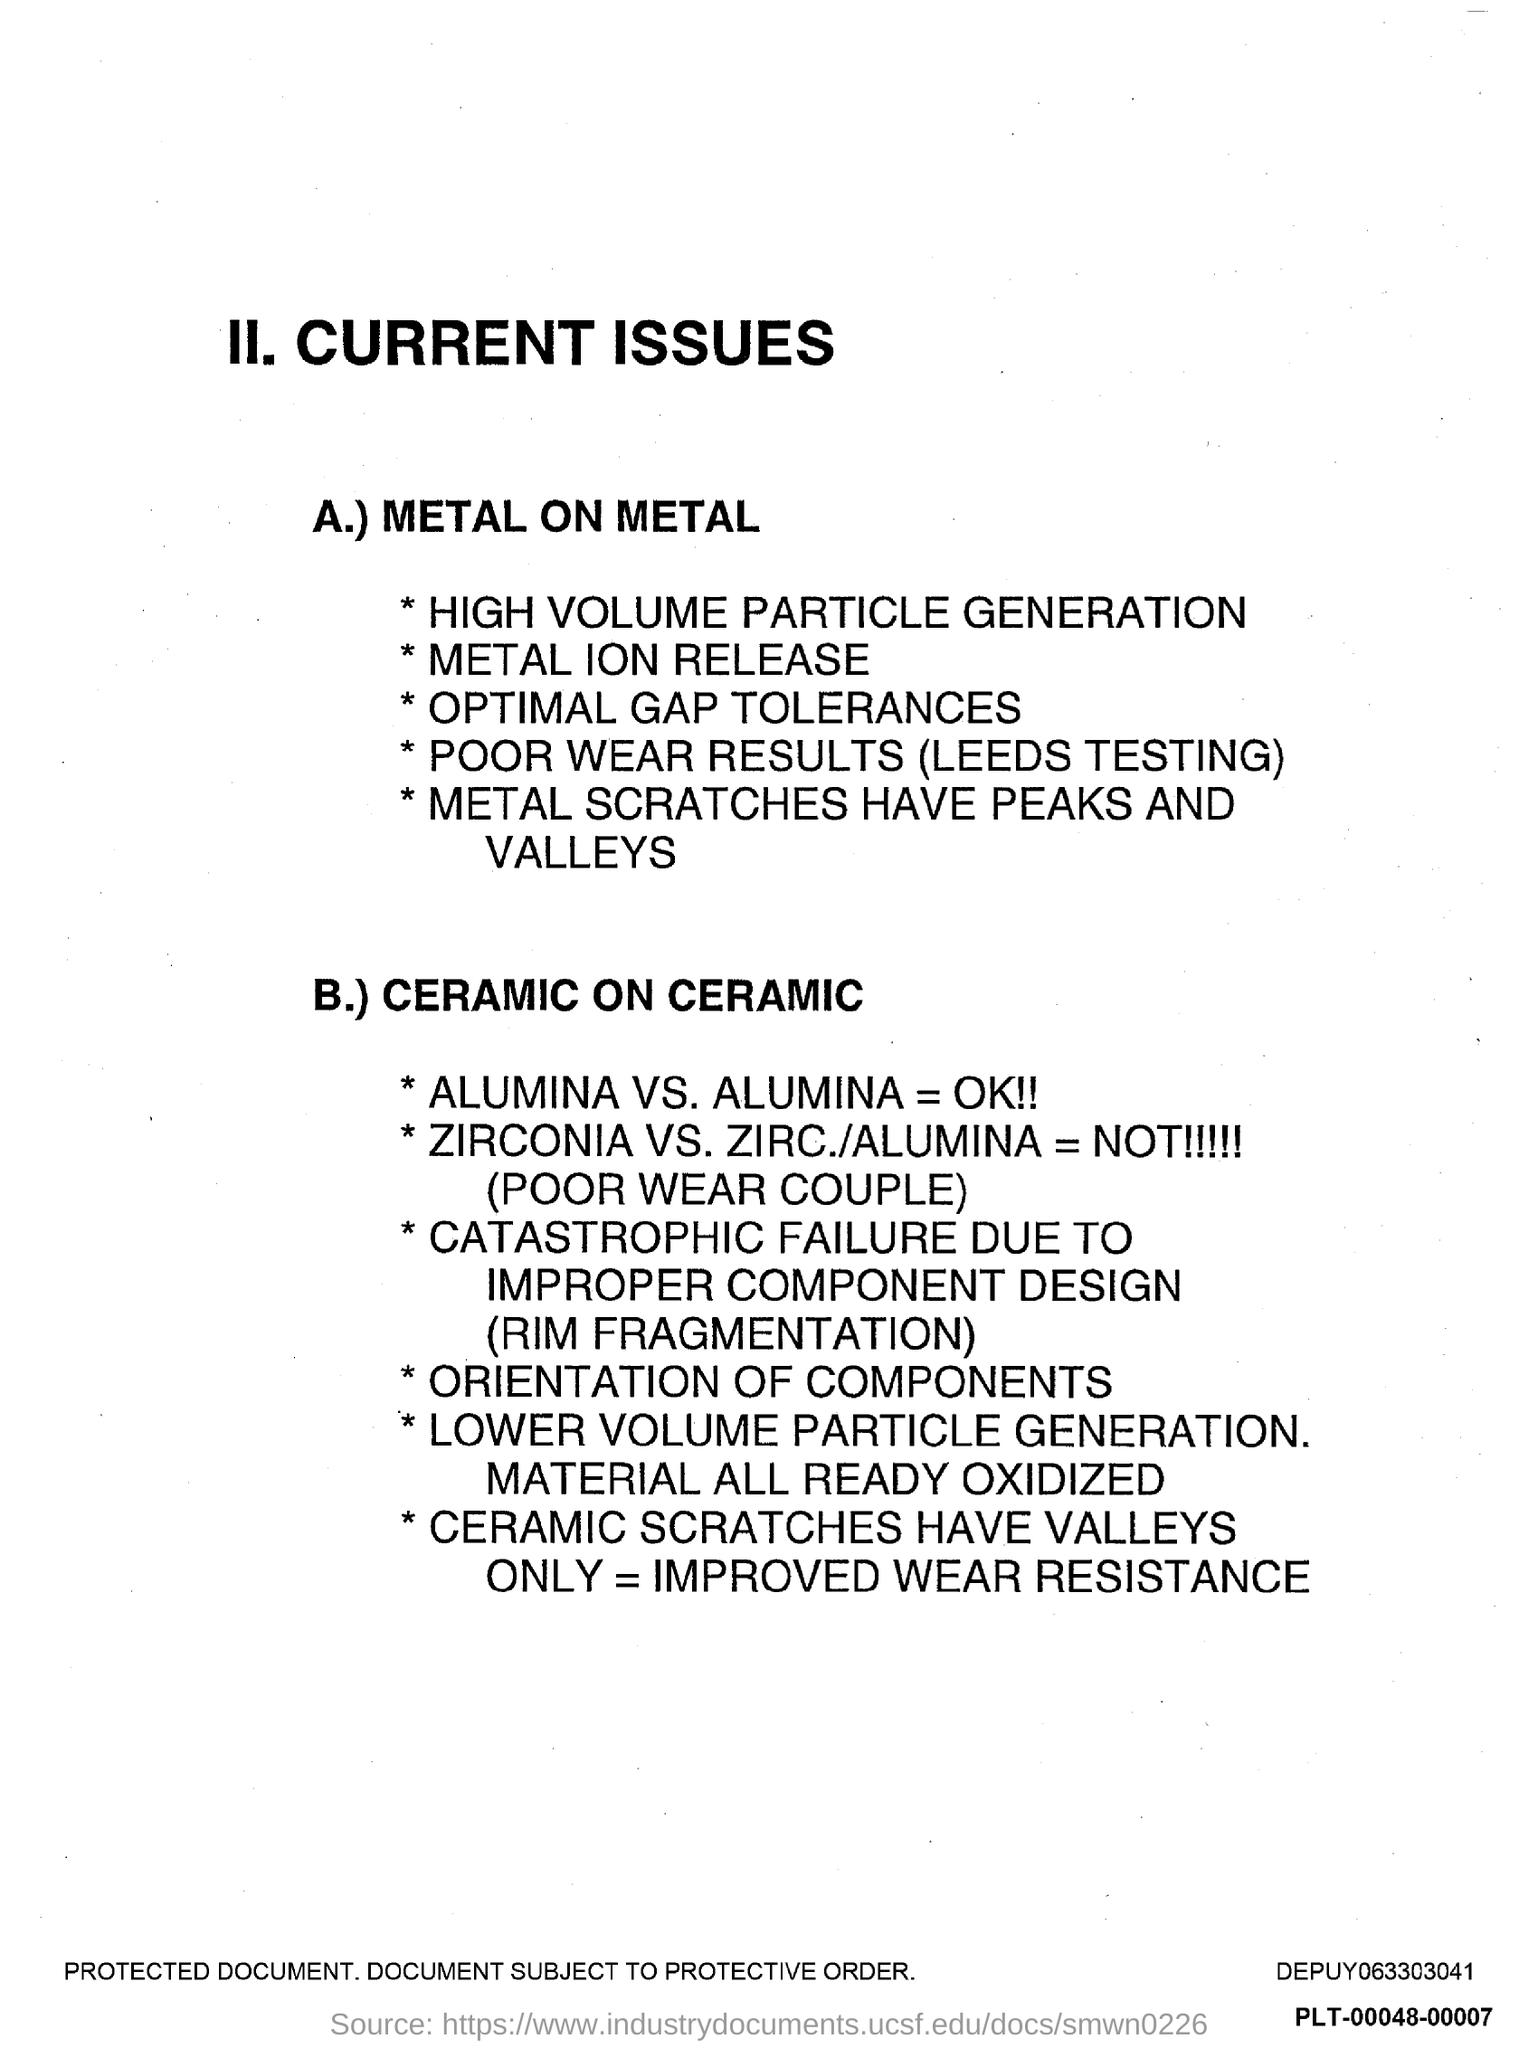Indicate a few pertinent items in this graphic. The first title in the document is II. Current Issues.. 